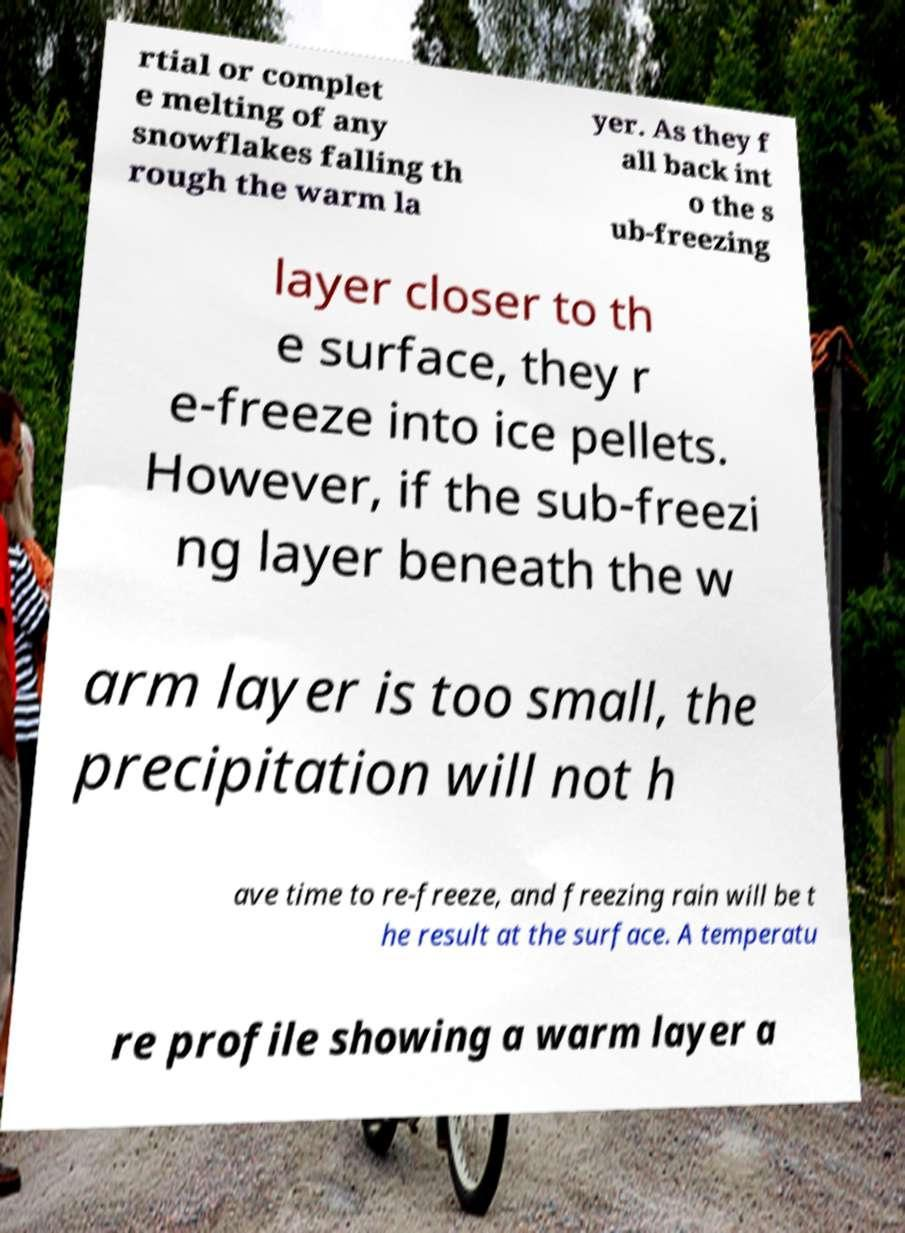Can you accurately transcribe the text from the provided image for me? rtial or complet e melting of any snowflakes falling th rough the warm la yer. As they f all back int o the s ub-freezing layer closer to th e surface, they r e-freeze into ice pellets. However, if the sub-freezi ng layer beneath the w arm layer is too small, the precipitation will not h ave time to re-freeze, and freezing rain will be t he result at the surface. A temperatu re profile showing a warm layer a 